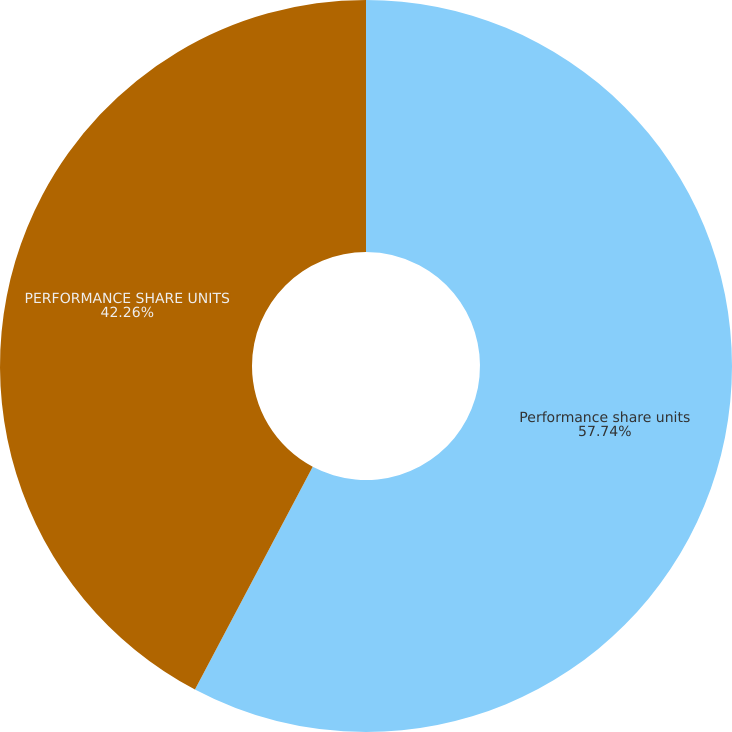<chart> <loc_0><loc_0><loc_500><loc_500><pie_chart><fcel>Performance share units<fcel>PERFORMANCE SHARE UNITS<nl><fcel>57.74%<fcel>42.26%<nl></chart> 